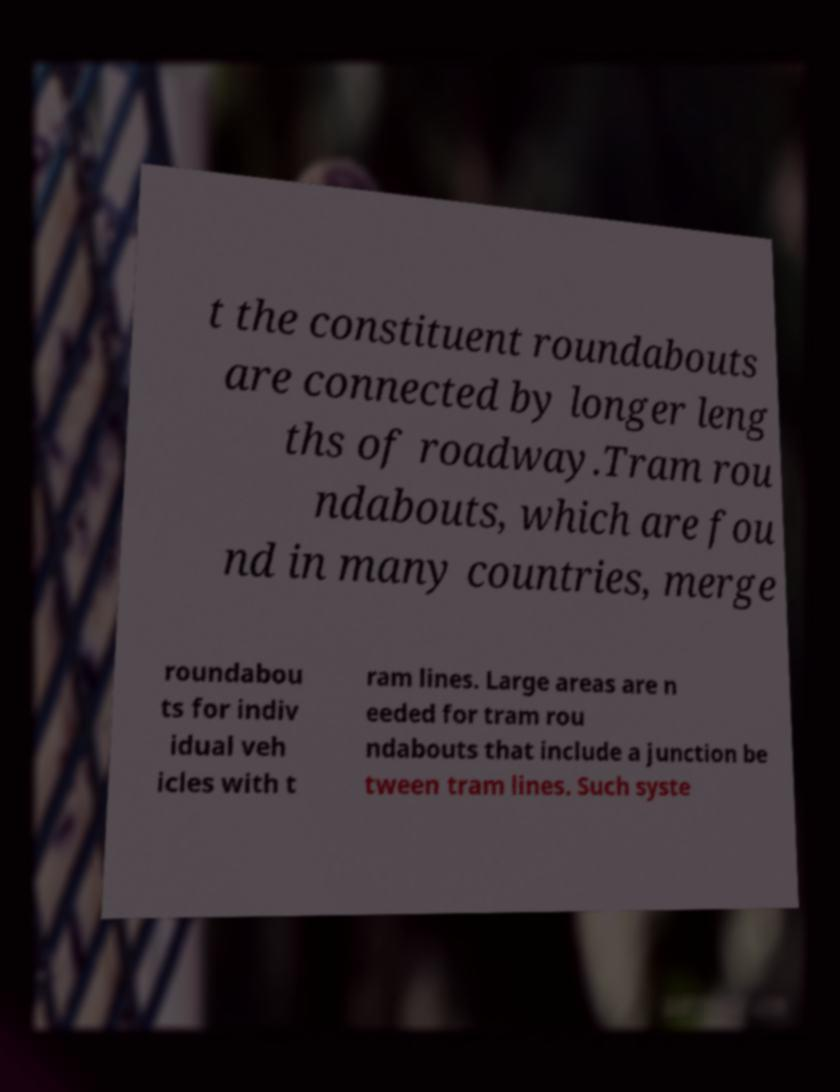Could you extract and type out the text from this image? t the constituent roundabouts are connected by longer leng ths of roadway.Tram rou ndabouts, which are fou nd in many countries, merge roundabou ts for indiv idual veh icles with t ram lines. Large areas are n eeded for tram rou ndabouts that include a junction be tween tram lines. Such syste 